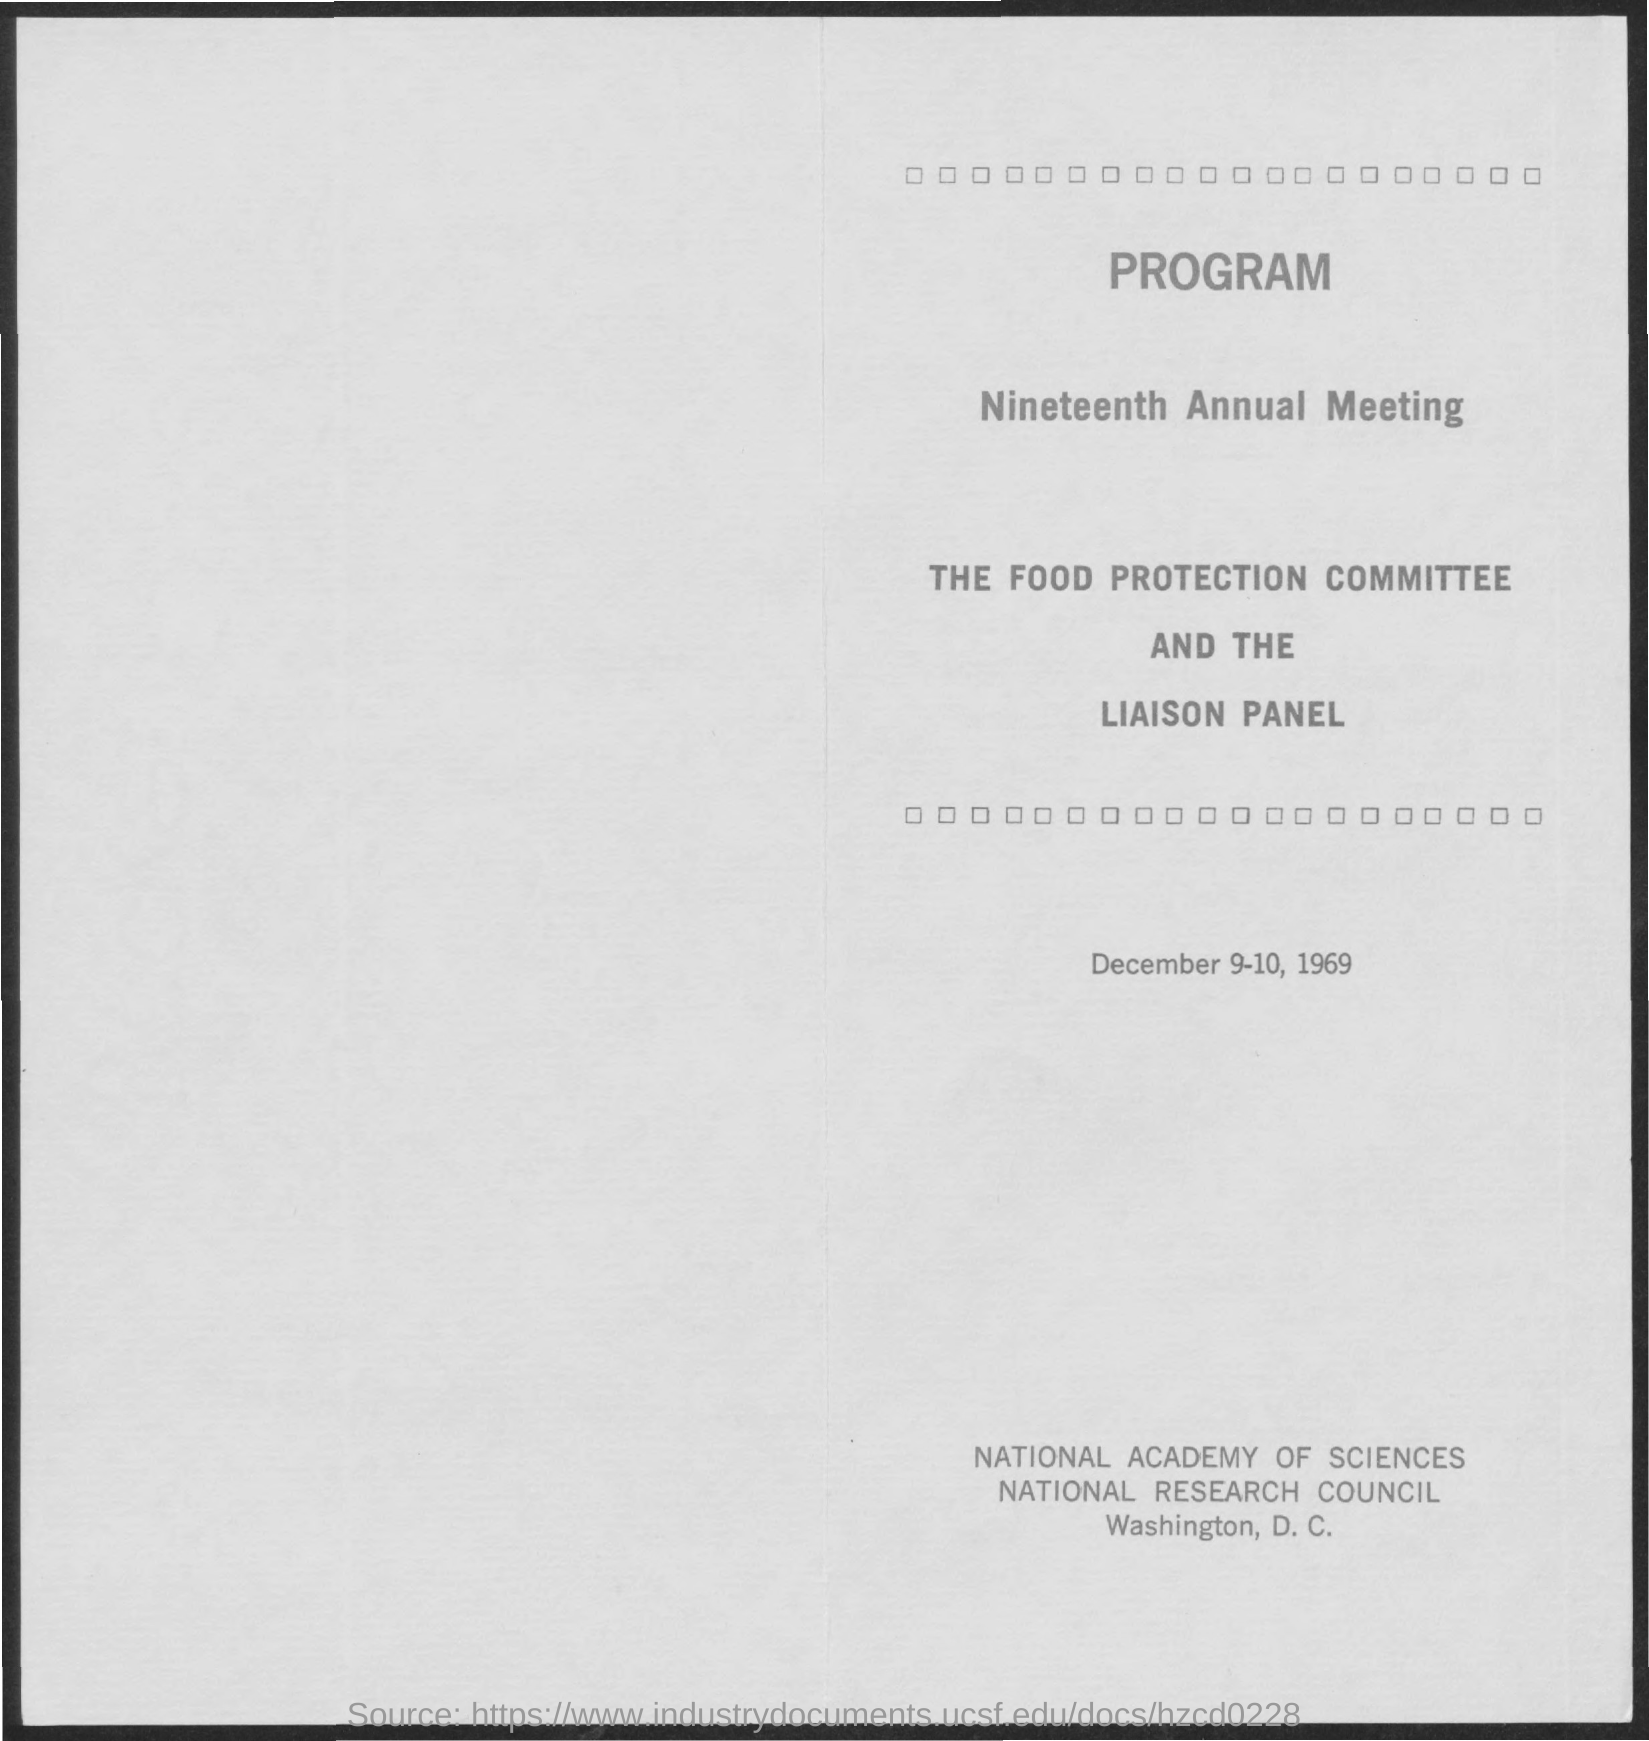Mention a couple of crucial points in this snapshot. The nineteenth annual meeting will be held on December 9-10, 1969. 